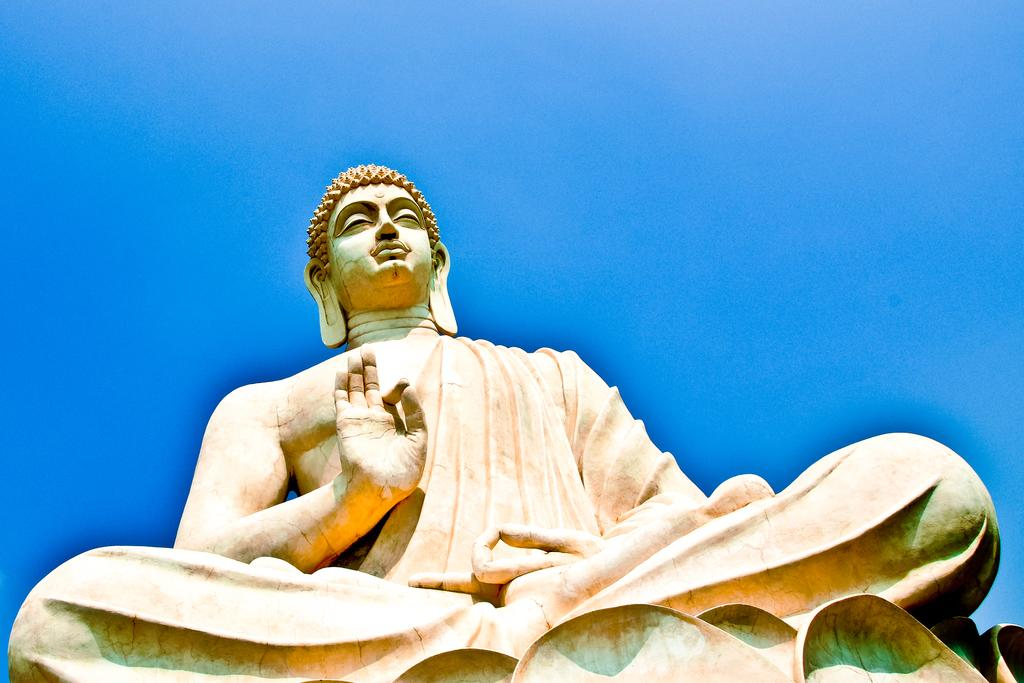What is the main subject of the image? The main subject of the image is a sculpture. Can you describe the sculpture in the image? The sculpture is of a meditating idol. What type of dirt can be seen accumulating on the arm of the idol in the image? There is no dirt visible on the idol in the image. How does the wind affect the meditating idol in the image? The image does not depict any wind or its effects on the idol. 